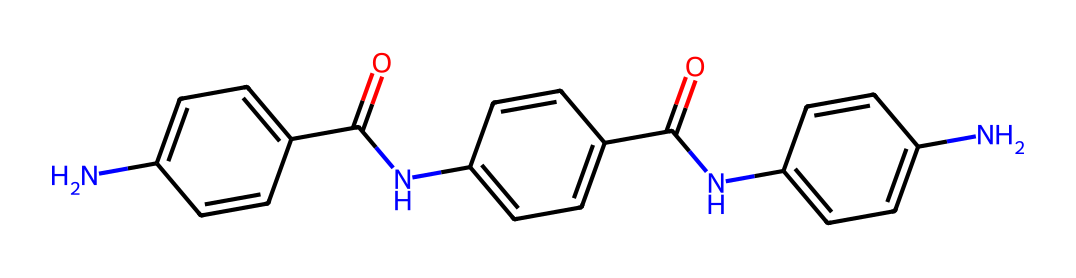What is the core structure of the Kevlar fiber? The core structure is primarily composed of aromatic rings linked by amide bonds. This is visible in the SMILES representation where the alternating carbon and nitrogen create a polymer backbone typical for fibers.
Answer: aromatic rings How many nitrogen atoms are present in this molecule? By analyzing the SMILES structure, we can count the nitrogen atoms. There are 3 nitrogen atoms in total.
Answer: 3 What type of bonding is predominant in Kevlar fibers? The predominant bonding type is hydrogen bonding, which occurs between the amide groups and contributes significantly to the fiber's strength and stability.
Answer: hydrogen bonding What is the molecular formula of Kevlar represented in the SMILES? By interpreting the elements and their counts from the SMILES, the molecular formula derived is C18H16N4O4.
Answer: C18H16N4O4 How does the presence of amide groups influence the properties of Kevlar? The amide groups are polar and capable of forming strong hydrogen bonds, which increase tensile strength and thermal resistance. This critical feature is represented in the chemical structure and accounts for Kevlar's applications in protective workwear.
Answer: increases tensile strength What property allows Kevlar fibers to be used in protective clothing? The superior tensile strength derived from its tightly woven structure significantly contributes to its use in protective clothing. This is a result of the rigid aromatic structure shown in the SMILES notation.
Answer: tensile strength 